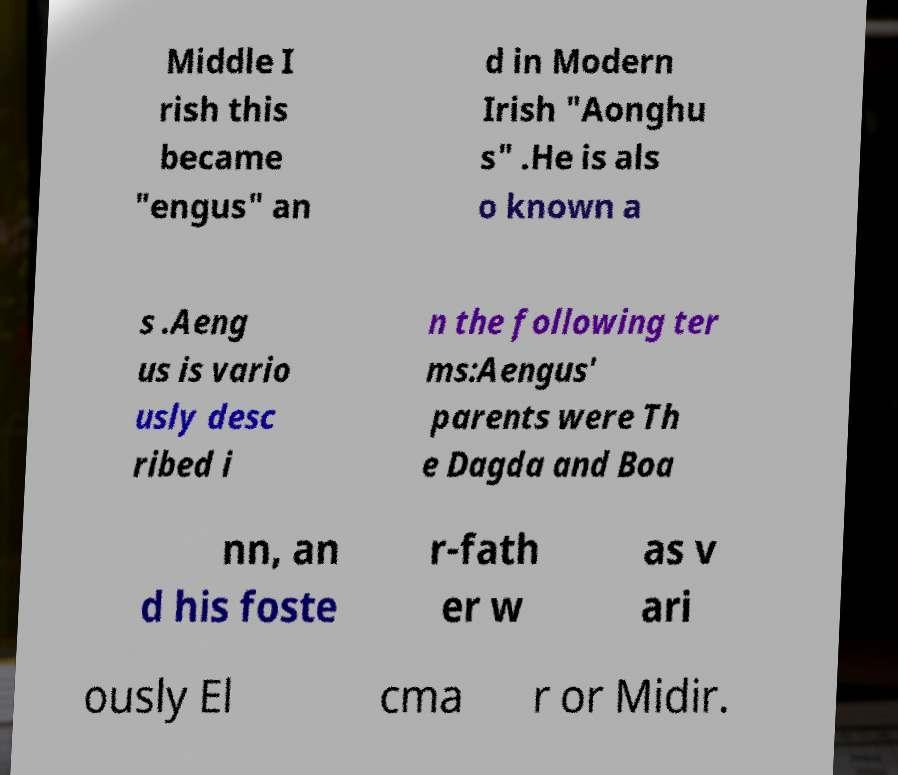For documentation purposes, I need the text within this image transcribed. Could you provide that? Middle I rish this became "engus" an d in Modern Irish "Aonghu s" .He is als o known a s .Aeng us is vario usly desc ribed i n the following ter ms:Aengus' parents were Th e Dagda and Boa nn, an d his foste r-fath er w as v ari ously El cma r or Midir. 